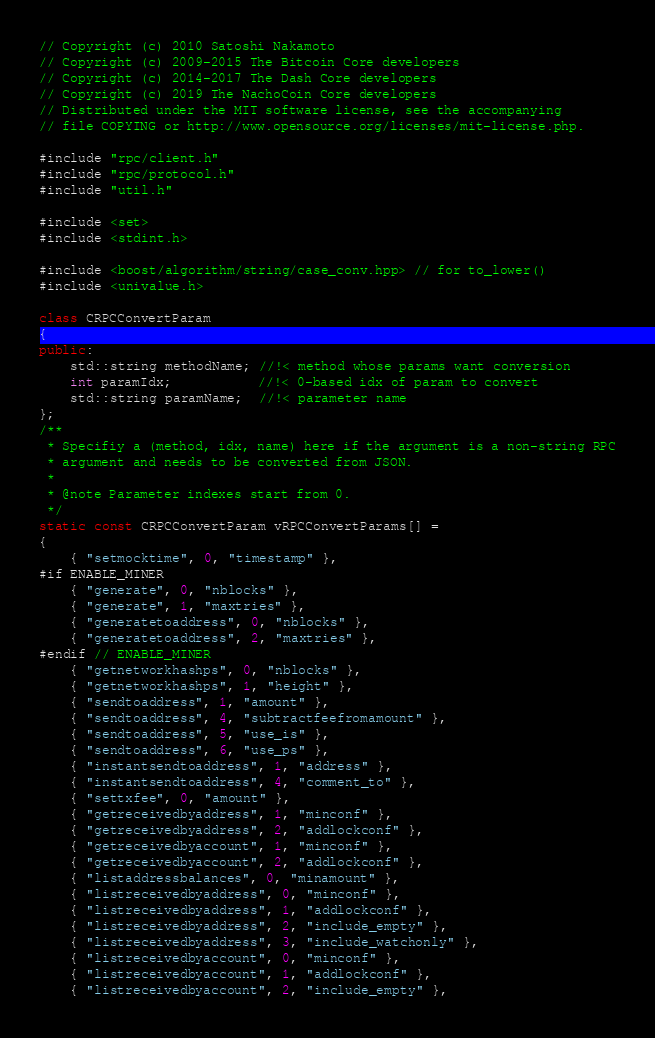Convert code to text. <code><loc_0><loc_0><loc_500><loc_500><_C++_>// Copyright (c) 2010 Satoshi Nakamoto
// Copyright (c) 2009-2015 The Bitcoin Core developers
// Copyright (c) 2014-2017 The Dash Core developers
// Copyright (c) 2019 The NachoCoin Core developers
// Distributed under the MIT software license, see the accompanying
// file COPYING or http://www.opensource.org/licenses/mit-license.php.

#include "rpc/client.h"
#include "rpc/protocol.h"
#include "util.h"

#include <set>
#include <stdint.h>

#include <boost/algorithm/string/case_conv.hpp> // for to_lower()
#include <univalue.h>

class CRPCConvertParam
{
public:
    std::string methodName; //!< method whose params want conversion
    int paramIdx;           //!< 0-based idx of param to convert
    std::string paramName;  //!< parameter name
};
/**
 * Specifiy a (method, idx, name) here if the argument is a non-string RPC
 * argument and needs to be converted from JSON.
 *
 * @note Parameter indexes start from 0.
 */
static const CRPCConvertParam vRPCConvertParams[] =
{
    { "setmocktime", 0, "timestamp" },
#if ENABLE_MINER
    { "generate", 0, "nblocks" },
    { "generate", 1, "maxtries" },
    { "generatetoaddress", 0, "nblocks" },
    { "generatetoaddress", 2, "maxtries" },
#endif // ENABLE_MINER
    { "getnetworkhashps", 0, "nblocks" },
    { "getnetworkhashps", 1, "height" },
    { "sendtoaddress", 1, "amount" },
    { "sendtoaddress", 4, "subtractfeefromamount" },
    { "sendtoaddress", 5, "use_is" },
    { "sendtoaddress", 6, "use_ps" },
    { "instantsendtoaddress", 1, "address" },
    { "instantsendtoaddress", 4, "comment_to" },
    { "settxfee", 0, "amount" },
    { "getreceivedbyaddress", 1, "minconf" },
    { "getreceivedbyaddress", 2, "addlockconf" },
    { "getreceivedbyaccount", 1, "minconf" },
    { "getreceivedbyaccount", 2, "addlockconf" },
    { "listaddressbalances", 0, "minamount" },
    { "listreceivedbyaddress", 0, "minconf" },
    { "listreceivedbyaddress", 1, "addlockconf" },
    { "listreceivedbyaddress", 2, "include_empty" },
    { "listreceivedbyaddress", 3, "include_watchonly" },
    { "listreceivedbyaccount", 0, "minconf" },
    { "listreceivedbyaccount", 1, "addlockconf" },
    { "listreceivedbyaccount", 2, "include_empty" },</code> 